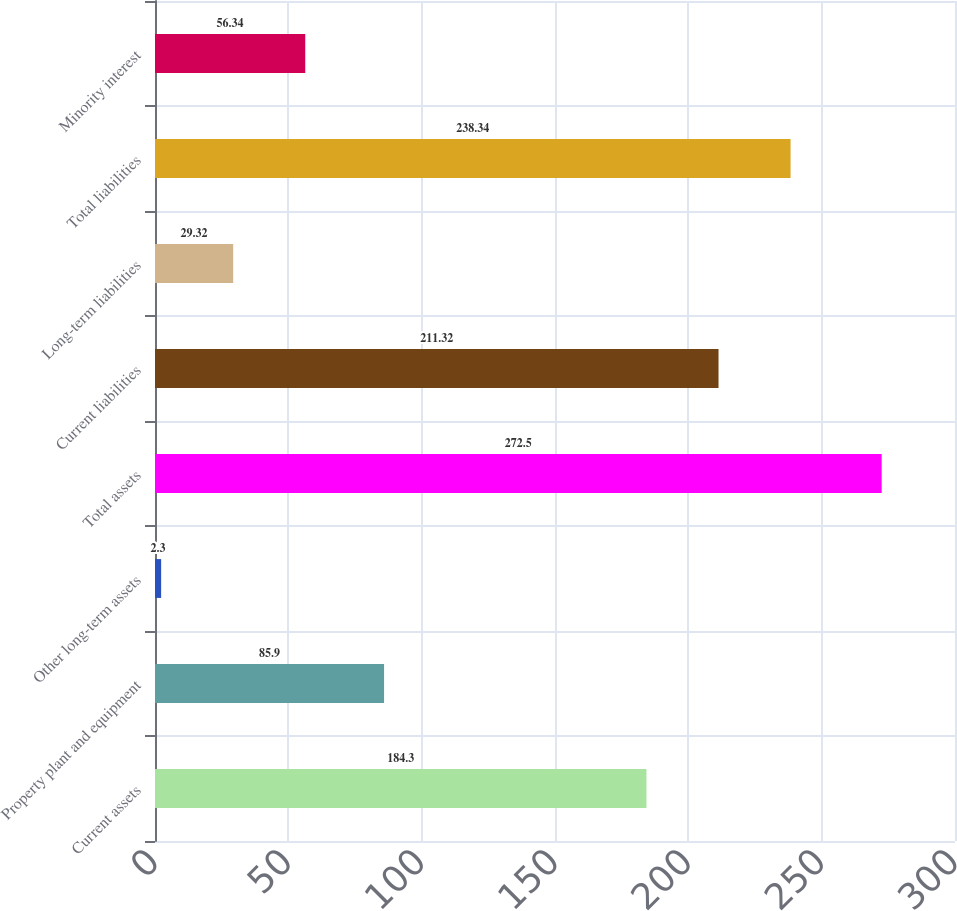Convert chart to OTSL. <chart><loc_0><loc_0><loc_500><loc_500><bar_chart><fcel>Current assets<fcel>Property plant and equipment<fcel>Other long-term assets<fcel>Total assets<fcel>Current liabilities<fcel>Long-term liabilities<fcel>Total liabilities<fcel>Minority interest<nl><fcel>184.3<fcel>85.9<fcel>2.3<fcel>272.5<fcel>211.32<fcel>29.32<fcel>238.34<fcel>56.34<nl></chart> 